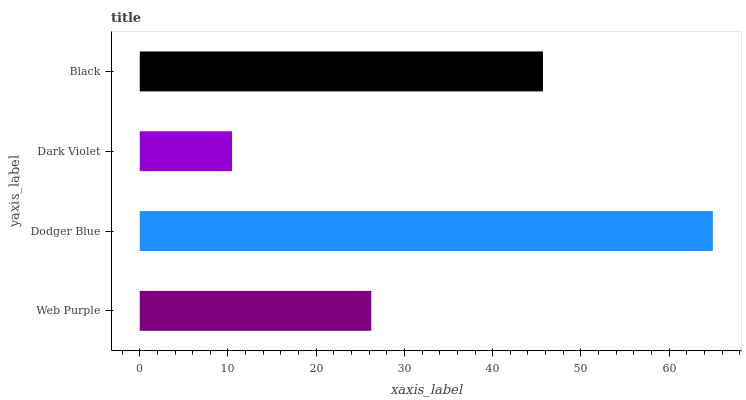Is Dark Violet the minimum?
Answer yes or no. Yes. Is Dodger Blue the maximum?
Answer yes or no. Yes. Is Dodger Blue the minimum?
Answer yes or no. No. Is Dark Violet the maximum?
Answer yes or no. No. Is Dodger Blue greater than Dark Violet?
Answer yes or no. Yes. Is Dark Violet less than Dodger Blue?
Answer yes or no. Yes. Is Dark Violet greater than Dodger Blue?
Answer yes or no. No. Is Dodger Blue less than Dark Violet?
Answer yes or no. No. Is Black the high median?
Answer yes or no. Yes. Is Web Purple the low median?
Answer yes or no. Yes. Is Web Purple the high median?
Answer yes or no. No. Is Dodger Blue the low median?
Answer yes or no. No. 